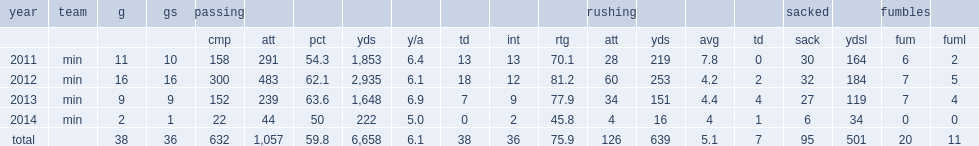How many rushing yards did ponder get in 2011? 219.0. 